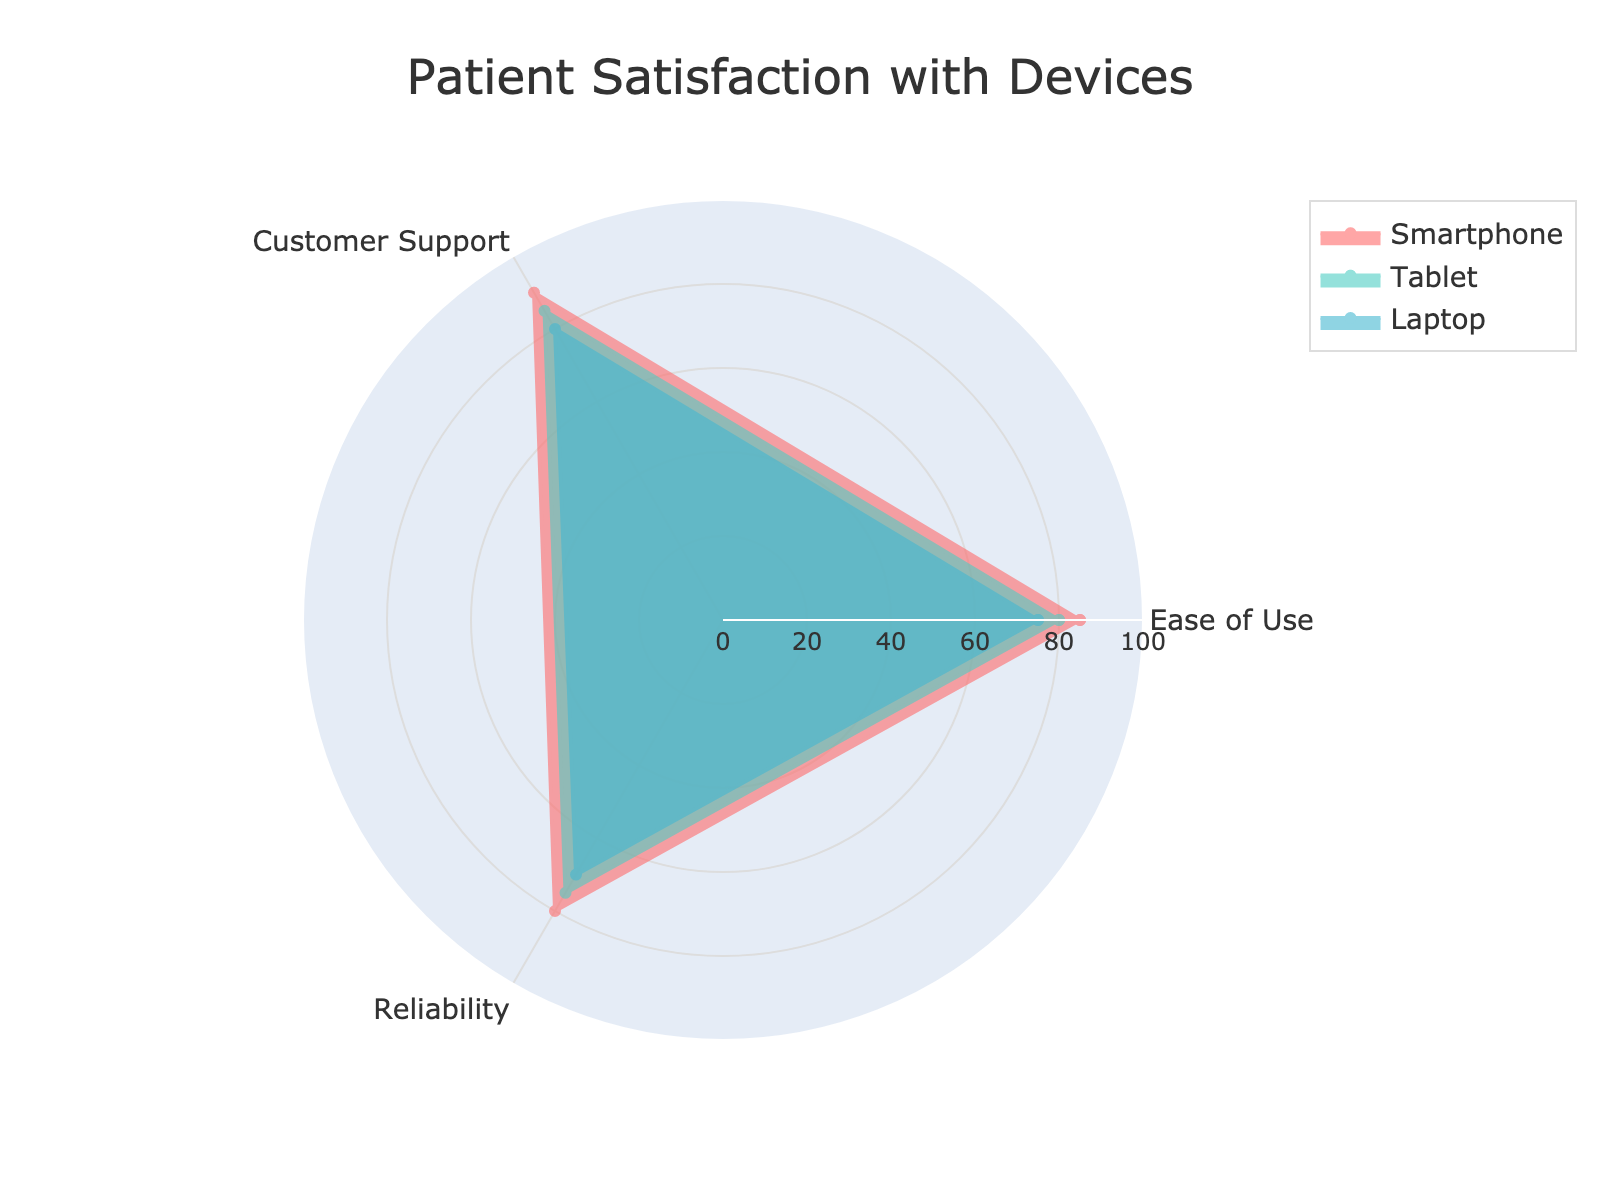what are the 3 categories in the radar chart? The categories mentioned in the radar chart are listed next to their respective axes. They are used to represent the criteria being evaluated for each device.
Answer: Ease of Use, Customer Support, Reliability which device has the highest score for Customer Support? The radar chart shows the scores for Customer Support for each device as plotted points along the 'Customer Support' axis. The device with the highest score here has its point closest to the outer edge.
Answer: Smartphone which device performs the best overall across all categories? To determine which device performs the best overall, we examine the areas covered by each device's plot. The larger the area or the closer the points are to the outer edges, the better the overall performance.
Answer: Smartphone compare the ease of use for all three devices. which one has the lowest score? Checking the Ease of Use axis, each device's score is plotted. The device with the point closest to the center has the lowest score.
Answer: Laptop what is the difference in reliability scores between the Tablet and Laptop? Find the positions of the Tablet and Laptop on the Reliability axis. Subtract the Laptop’s score from the Tablet’s score to get the difference.
Answer: 5 which device has the most balanced performance across all categories? A balanced performance would mean the device scores similarly across all categories, implying a more circular plot. Examine which device's plot looks the most circular and covers the same or similar distance from the center.
Answer: Tablet average the ease of use scores for all the devices. what is the result? Sum the Ease of Use scores for Smartphone (85), Tablet (80), and Laptop (75), then divide by the number of devices: (85 + 80 + 75) / 3 = 240 / 3.
Answer: 80 does any device have the same score for multiple categories? if so, which one and for which categories? Check each device's plot points across the categories for any overlaps. No two categories for any device have the same score.
Answer: No between the Tablet and Laptop, which device has a higher score for Customer Support? Look at the points for Tablet and Laptop on the Customer Support axis. The one closer to the outer edge has a higher score.
Answer: Tablet 